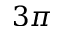Convert formula to latex. <formula><loc_0><loc_0><loc_500><loc_500>3 \pi</formula> 